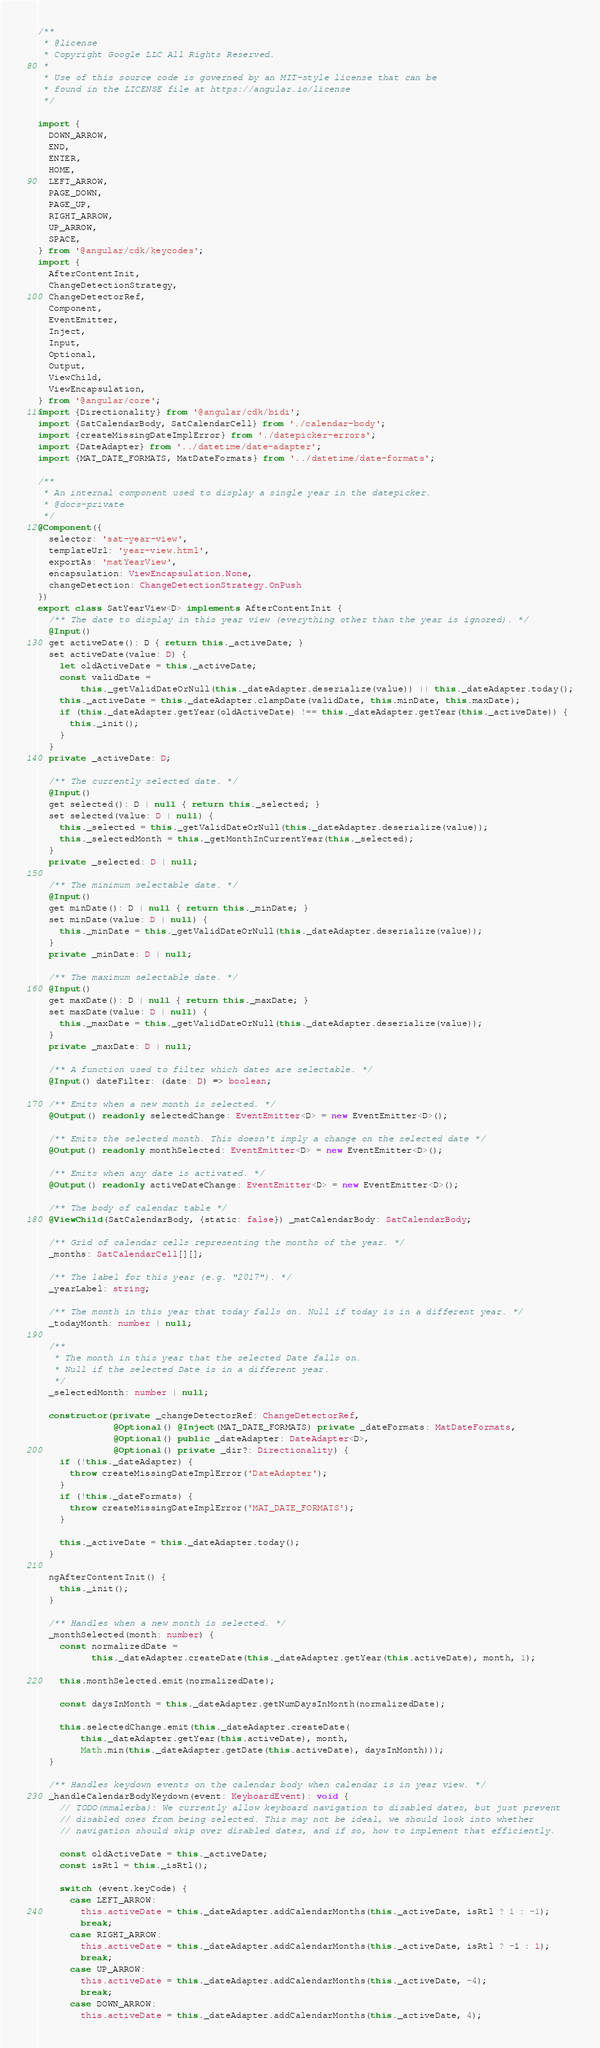<code> <loc_0><loc_0><loc_500><loc_500><_TypeScript_>/**
 * @license
 * Copyright Google LLC All Rights Reserved.
 *
 * Use of this source code is governed by an MIT-style license that can be
 * found in the LICENSE file at https://angular.io/license
 */

import {
  DOWN_ARROW,
  END,
  ENTER,
  HOME,
  LEFT_ARROW,
  PAGE_DOWN,
  PAGE_UP,
  RIGHT_ARROW,
  UP_ARROW,
  SPACE,
} from '@angular/cdk/keycodes';
import {
  AfterContentInit,
  ChangeDetectionStrategy,
  ChangeDetectorRef,
  Component,
  EventEmitter,
  Inject,
  Input,
  Optional,
  Output,
  ViewChild,
  ViewEncapsulation,
} from '@angular/core';
import {Directionality} from '@angular/cdk/bidi';
import {SatCalendarBody, SatCalendarCell} from './calendar-body';
import {createMissingDateImplError} from './datepicker-errors';
import {DateAdapter} from '../datetime/date-adapter';
import {MAT_DATE_FORMATS, MatDateFormats} from '../datetime/date-formats';

/**
 * An internal component used to display a single year in the datepicker.
 * @docs-private
 */
@Component({
  selector: 'sat-year-view',
  templateUrl: 'year-view.html',
  exportAs: 'matYearView',
  encapsulation: ViewEncapsulation.None,
  changeDetection: ChangeDetectionStrategy.OnPush
})
export class SatYearView<D> implements AfterContentInit {
  /** The date to display in this year view (everything other than the year is ignored). */
  @Input()
  get activeDate(): D { return this._activeDate; }
  set activeDate(value: D) {
    let oldActiveDate = this._activeDate;
    const validDate =
        this._getValidDateOrNull(this._dateAdapter.deserialize(value)) || this._dateAdapter.today();
    this._activeDate = this._dateAdapter.clampDate(validDate, this.minDate, this.maxDate);
    if (this._dateAdapter.getYear(oldActiveDate) !== this._dateAdapter.getYear(this._activeDate)) {
      this._init();
    }
  }
  private _activeDate: D;

  /** The currently selected date. */
  @Input()
  get selected(): D | null { return this._selected; }
  set selected(value: D | null) {
    this._selected = this._getValidDateOrNull(this._dateAdapter.deserialize(value));
    this._selectedMonth = this._getMonthInCurrentYear(this._selected);
  }
  private _selected: D | null;

  /** The minimum selectable date. */
  @Input()
  get minDate(): D | null { return this._minDate; }
  set minDate(value: D | null) {
    this._minDate = this._getValidDateOrNull(this._dateAdapter.deserialize(value));
  }
  private _minDate: D | null;

  /** The maximum selectable date. */
  @Input()
  get maxDate(): D | null { return this._maxDate; }
  set maxDate(value: D | null) {
    this._maxDate = this._getValidDateOrNull(this._dateAdapter.deserialize(value));
  }
  private _maxDate: D | null;

  /** A function used to filter which dates are selectable. */
  @Input() dateFilter: (date: D) => boolean;

  /** Emits when a new month is selected. */
  @Output() readonly selectedChange: EventEmitter<D> = new EventEmitter<D>();

  /** Emits the selected month. This doesn't imply a change on the selected date */
  @Output() readonly monthSelected: EventEmitter<D> = new EventEmitter<D>();

  /** Emits when any date is activated. */
  @Output() readonly activeDateChange: EventEmitter<D> = new EventEmitter<D>();

  /** The body of calendar table */
  @ViewChild(SatCalendarBody, {static: false}) _matCalendarBody: SatCalendarBody;

  /** Grid of calendar cells representing the months of the year. */
  _months: SatCalendarCell[][];

  /** The label for this year (e.g. "2017"). */
  _yearLabel: string;

  /** The month in this year that today falls on. Null if today is in a different year. */
  _todayMonth: number | null;

  /**
   * The month in this year that the selected Date falls on.
   * Null if the selected Date is in a different year.
   */
  _selectedMonth: number | null;

  constructor(private _changeDetectorRef: ChangeDetectorRef,
              @Optional() @Inject(MAT_DATE_FORMATS) private _dateFormats: MatDateFormats,
              @Optional() public _dateAdapter: DateAdapter<D>,
              @Optional() private _dir?: Directionality) {
    if (!this._dateAdapter) {
      throw createMissingDateImplError('DateAdapter');
    }
    if (!this._dateFormats) {
      throw createMissingDateImplError('MAT_DATE_FORMATS');
    }

    this._activeDate = this._dateAdapter.today();
  }

  ngAfterContentInit() {
    this._init();
  }

  /** Handles when a new month is selected. */
  _monthSelected(month: number) {
    const normalizedDate =
          this._dateAdapter.createDate(this._dateAdapter.getYear(this.activeDate), month, 1);

    this.monthSelected.emit(normalizedDate);

    const daysInMonth = this._dateAdapter.getNumDaysInMonth(normalizedDate);

    this.selectedChange.emit(this._dateAdapter.createDate(
        this._dateAdapter.getYear(this.activeDate), month,
        Math.min(this._dateAdapter.getDate(this.activeDate), daysInMonth)));
  }

  /** Handles keydown events on the calendar body when calendar is in year view. */
  _handleCalendarBodyKeydown(event: KeyboardEvent): void {
    // TODO(mmalerba): We currently allow keyboard navigation to disabled dates, but just prevent
    // disabled ones from being selected. This may not be ideal, we should look into whether
    // navigation should skip over disabled dates, and if so, how to implement that efficiently.

    const oldActiveDate = this._activeDate;
    const isRtl = this._isRtl();

    switch (event.keyCode) {
      case LEFT_ARROW:
        this.activeDate = this._dateAdapter.addCalendarMonths(this._activeDate, isRtl ? 1 : -1);
        break;
      case RIGHT_ARROW:
        this.activeDate = this._dateAdapter.addCalendarMonths(this._activeDate, isRtl ? -1 : 1);
        break;
      case UP_ARROW:
        this.activeDate = this._dateAdapter.addCalendarMonths(this._activeDate, -4);
        break;
      case DOWN_ARROW:
        this.activeDate = this._dateAdapter.addCalendarMonths(this._activeDate, 4);</code> 